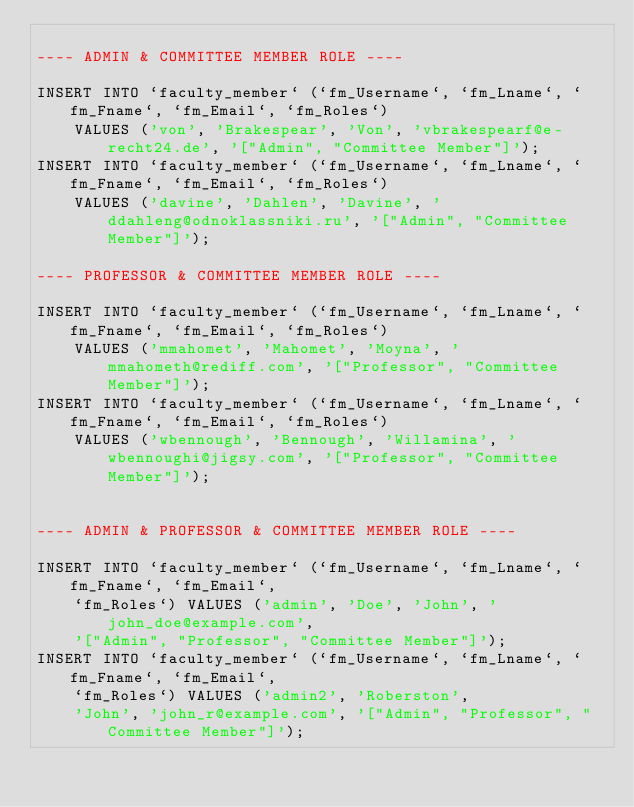<code> <loc_0><loc_0><loc_500><loc_500><_SQL_>
---- ADMIN & COMMITTEE MEMBER ROLE ----

INSERT INTO `faculty_member` (`fm_Username`, `fm_Lname`, `fm_Fname`, `fm_Email`, `fm_Roles`)
    VALUES ('von', 'Brakespear', 'Von', 'vbrakespearf@e-recht24.de', '["Admin", "Committee Member"]');
INSERT INTO `faculty_member` (`fm_Username`, `fm_Lname`, `fm_Fname`, `fm_Email`, `fm_Roles`)
    VALUES ('davine', 'Dahlen', 'Davine', 'ddahleng@odnoklassniki.ru', '["Admin", "Committee Member"]');

---- PROFESSOR & COMMITTEE MEMBER ROLE ----

INSERT INTO `faculty_member` (`fm_Username`, `fm_Lname`, `fm_Fname`, `fm_Email`, `fm_Roles`)
    VALUES ('mmahomet', 'Mahomet', 'Moyna', 'mmahometh@rediff.com', '["Professor", "Committee Member"]');
INSERT INTO `faculty_member` (`fm_Username`, `fm_Lname`, `fm_Fname`, `fm_Email`, `fm_Roles`)
    VALUES ('wbennough', 'Bennough', 'Willamina', 'wbennoughi@jigsy.com', '["Professor", "Committee Member"]');


---- ADMIN & PROFESSOR & COMMITTEE MEMBER ROLE ----

INSERT INTO `faculty_member` (`fm_Username`, `fm_Lname`, `fm_Fname`, `fm_Email`,
    `fm_Roles`) VALUES ('admin', 'Doe', 'John', 'john_doe@example.com',
    '["Admin", "Professor", "Committee Member"]');
INSERT INTO `faculty_member` (`fm_Username`, `fm_Lname`, `fm_Fname`, `fm_Email`,
    `fm_Roles`) VALUES ('admin2', 'Roberston',
    'John', 'john_r@example.com', '["Admin", "Professor", "Committee Member"]');
</code> 